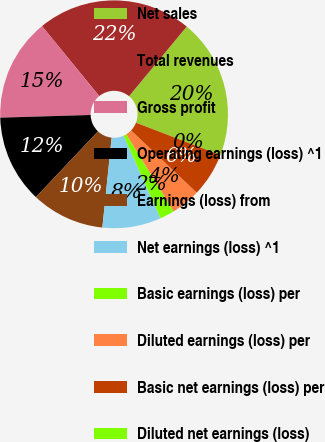Convert chart. <chart><loc_0><loc_0><loc_500><loc_500><pie_chart><fcel>Net sales<fcel>Total revenues<fcel>Gross profit<fcel>Operating earnings (loss) ^1<fcel>Earnings (loss) from<fcel>Net earnings (loss) ^1<fcel>Basic earnings (loss) per<fcel>Diluted earnings (loss) per<fcel>Basic net earnings (loss) per<fcel>Diluted net earnings (loss)<nl><fcel>19.83%<fcel>21.91%<fcel>14.57%<fcel>12.49%<fcel>10.4%<fcel>8.32%<fcel>2.08%<fcel>4.16%<fcel>6.24%<fcel>0.0%<nl></chart> 